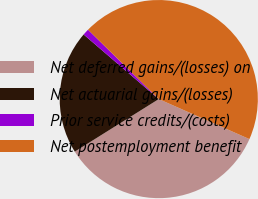Convert chart to OTSL. <chart><loc_0><loc_0><loc_500><loc_500><pie_chart><fcel>Net deferred gains/(losses) on<fcel>Net actuarial gains/(losses)<fcel>Prior service credits/(costs)<fcel>Net postemployment benefit<nl><fcel>34.48%<fcel>20.2%<fcel>1.04%<fcel>44.27%<nl></chart> 